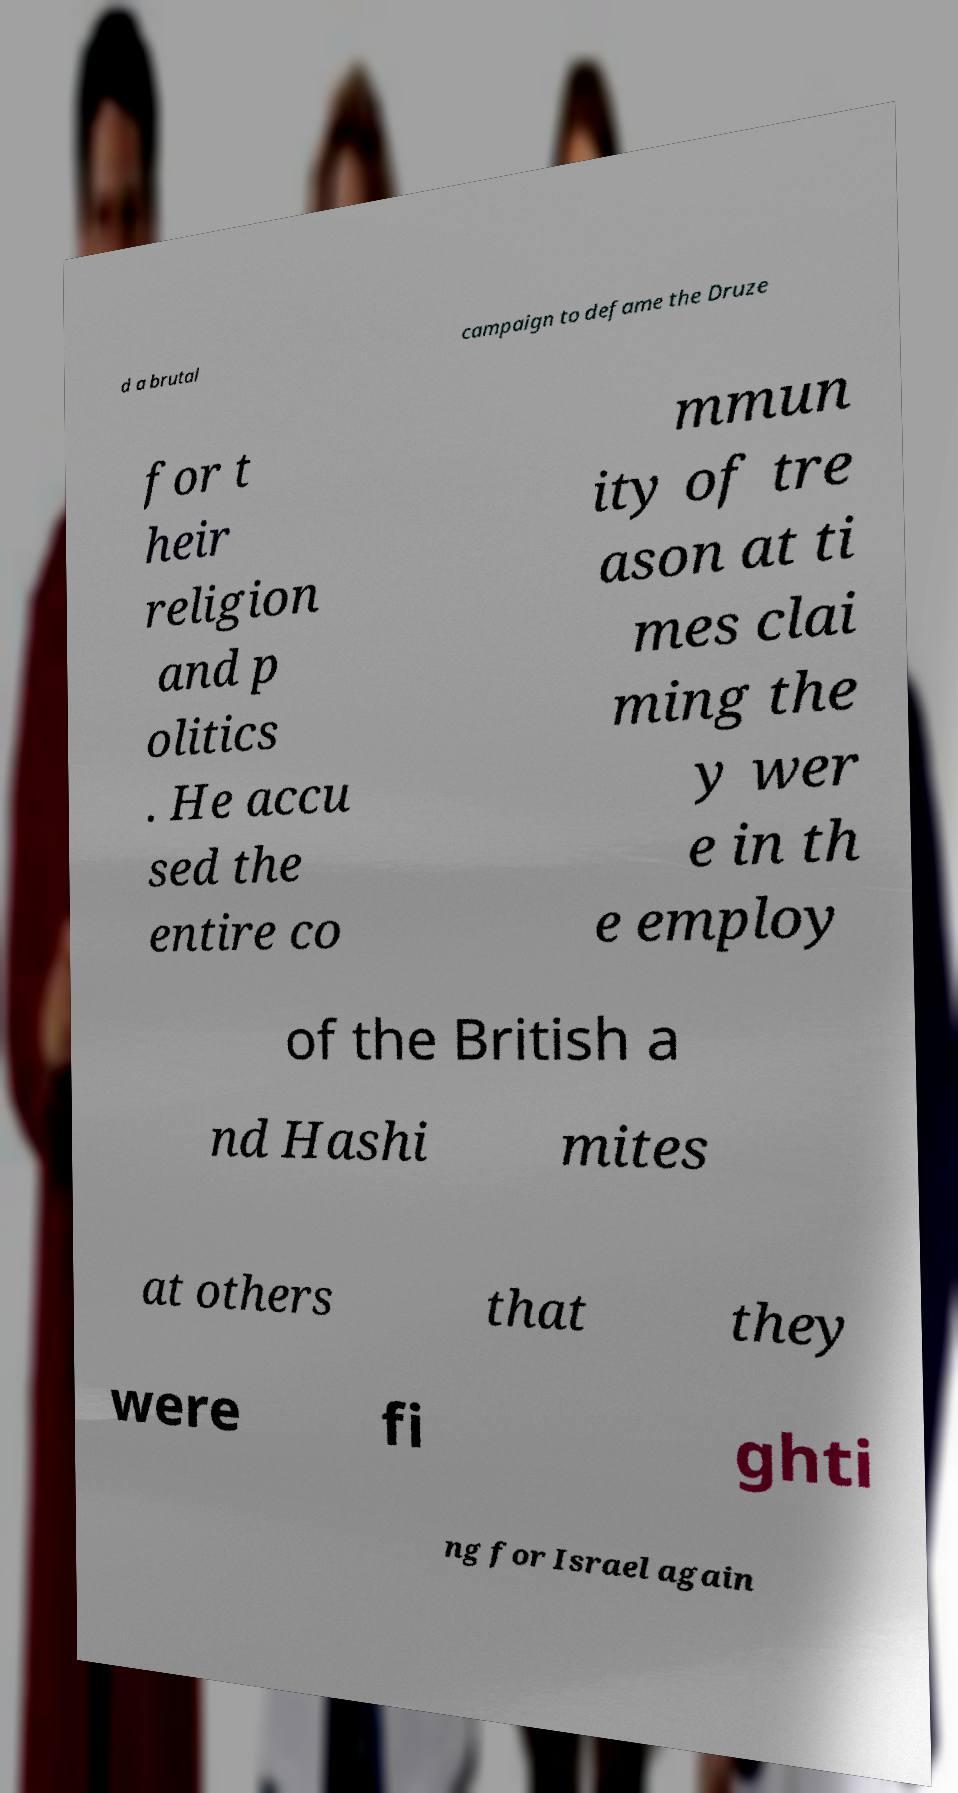What messages or text are displayed in this image? I need them in a readable, typed format. d a brutal campaign to defame the Druze for t heir religion and p olitics . He accu sed the entire co mmun ity of tre ason at ti mes clai ming the y wer e in th e employ of the British a nd Hashi mites at others that they were fi ghti ng for Israel again 